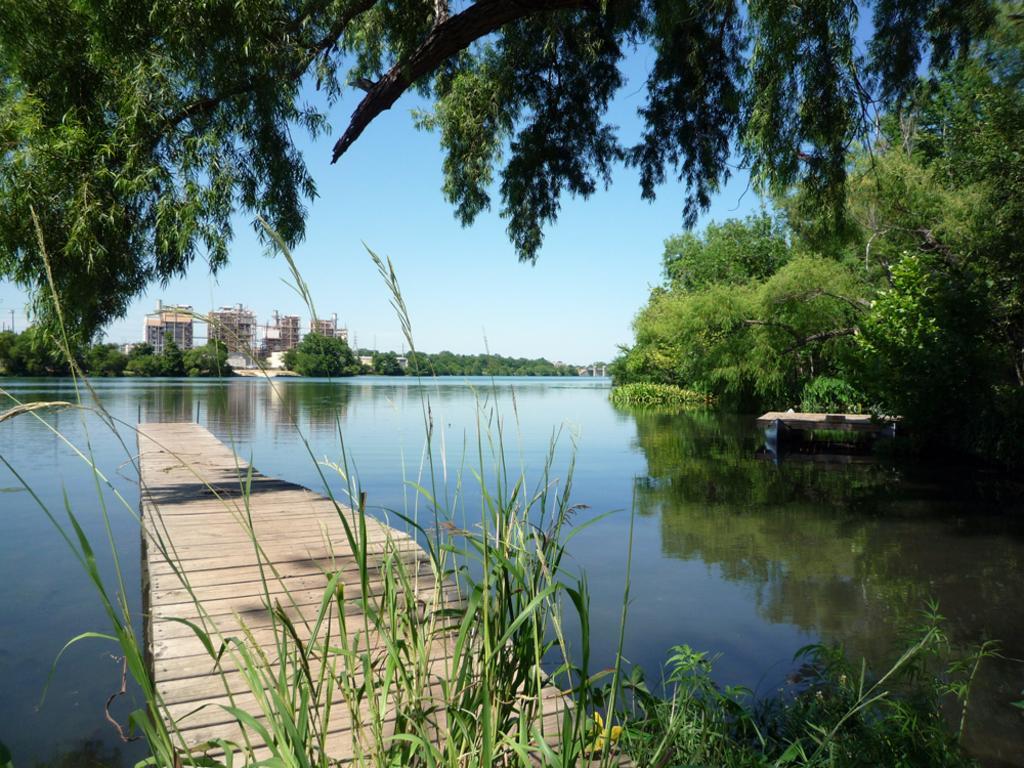Please provide a concise description of this image. In this image I can see trees, buildings, a boat on the water and plants. In the background I can see the sky. 